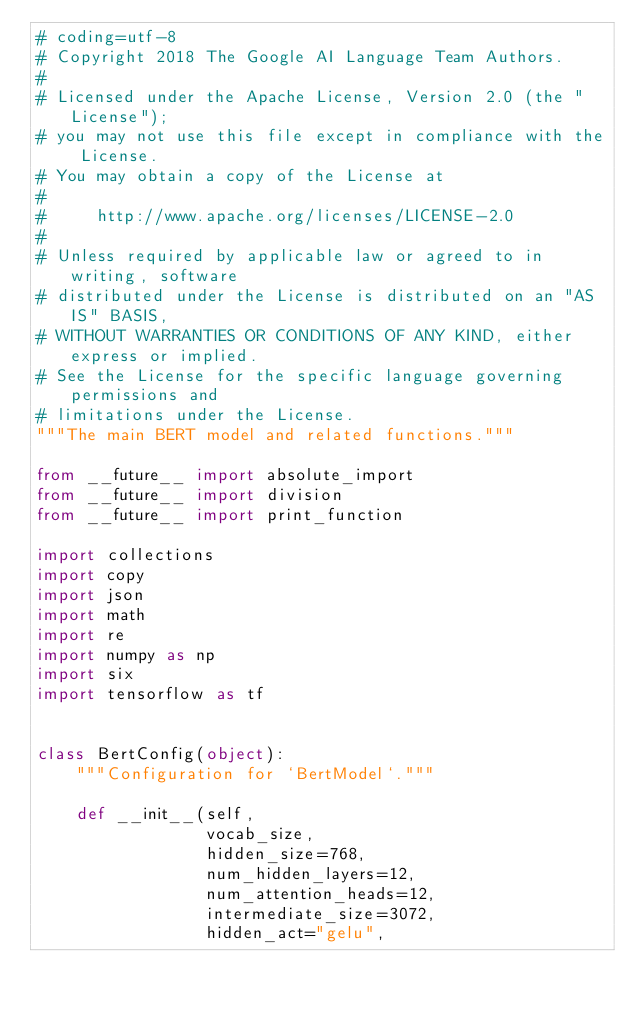<code> <loc_0><loc_0><loc_500><loc_500><_Python_># coding=utf-8
# Copyright 2018 The Google AI Language Team Authors.
#
# Licensed under the Apache License, Version 2.0 (the "License");
# you may not use this file except in compliance with the License.
# You may obtain a copy of the License at
#
#     http://www.apache.org/licenses/LICENSE-2.0
#
# Unless required by applicable law or agreed to in writing, software
# distributed under the License is distributed on an "AS IS" BASIS,
# WITHOUT WARRANTIES OR CONDITIONS OF ANY KIND, either express or implied.
# See the License for the specific language governing permissions and
# limitations under the License.
"""The main BERT model and related functions."""

from __future__ import absolute_import
from __future__ import division
from __future__ import print_function

import collections
import copy
import json
import math
import re
import numpy as np
import six
import tensorflow as tf


class BertConfig(object):
    """Configuration for `BertModel`."""

    def __init__(self,
                 vocab_size,
                 hidden_size=768,
                 num_hidden_layers=12,
                 num_attention_heads=12,
                 intermediate_size=3072,
                 hidden_act="gelu",</code> 